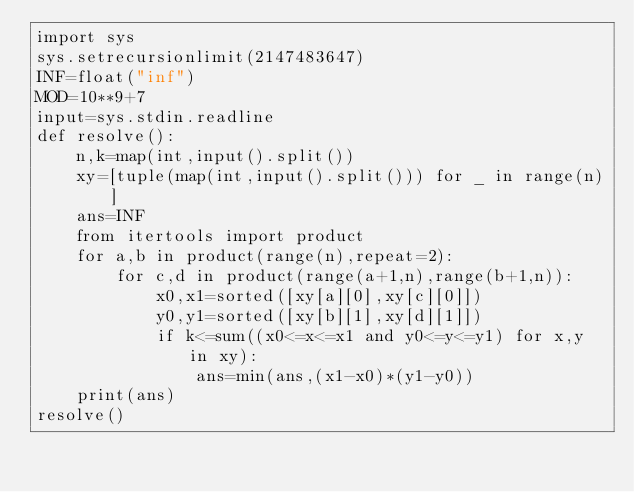<code> <loc_0><loc_0><loc_500><loc_500><_Python_>import sys
sys.setrecursionlimit(2147483647)
INF=float("inf")
MOD=10**9+7
input=sys.stdin.readline
def resolve():
    n,k=map(int,input().split())
    xy=[tuple(map(int,input().split())) for _ in range(n)]
    ans=INF
    from itertools import product
    for a,b in product(range(n),repeat=2):
        for c,d in product(range(a+1,n),range(b+1,n)):
            x0,x1=sorted([xy[a][0],xy[c][0]])
            y0,y1=sorted([xy[b][1],xy[d][1]])
            if k<=sum((x0<=x<=x1 and y0<=y<=y1) for x,y in xy):
                ans=min(ans,(x1-x0)*(y1-y0))
    print(ans)
resolve()</code> 